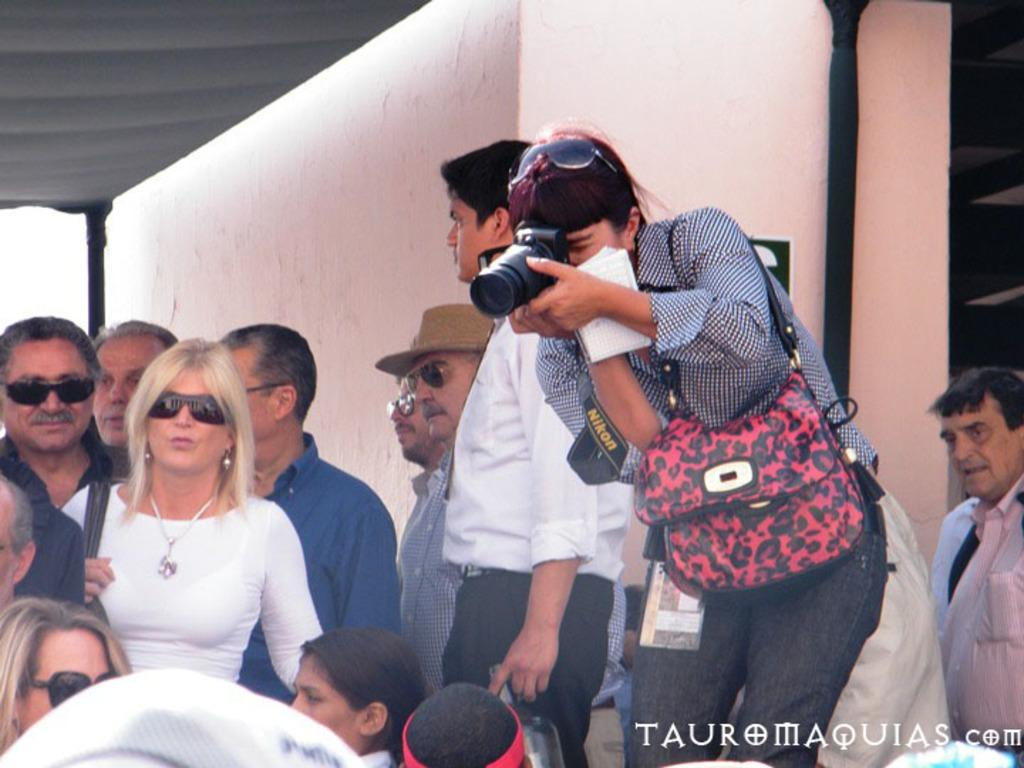What is happening in the image? There are people standing in the image. Can you describe any specific actions or objects in the image? Yes, there is a person holding a camera in her hand. What type of prose is being read by the person in the image? There is no indication in the image that anyone is reading prose, as the focus is on the people standing and the person holding a camera. 